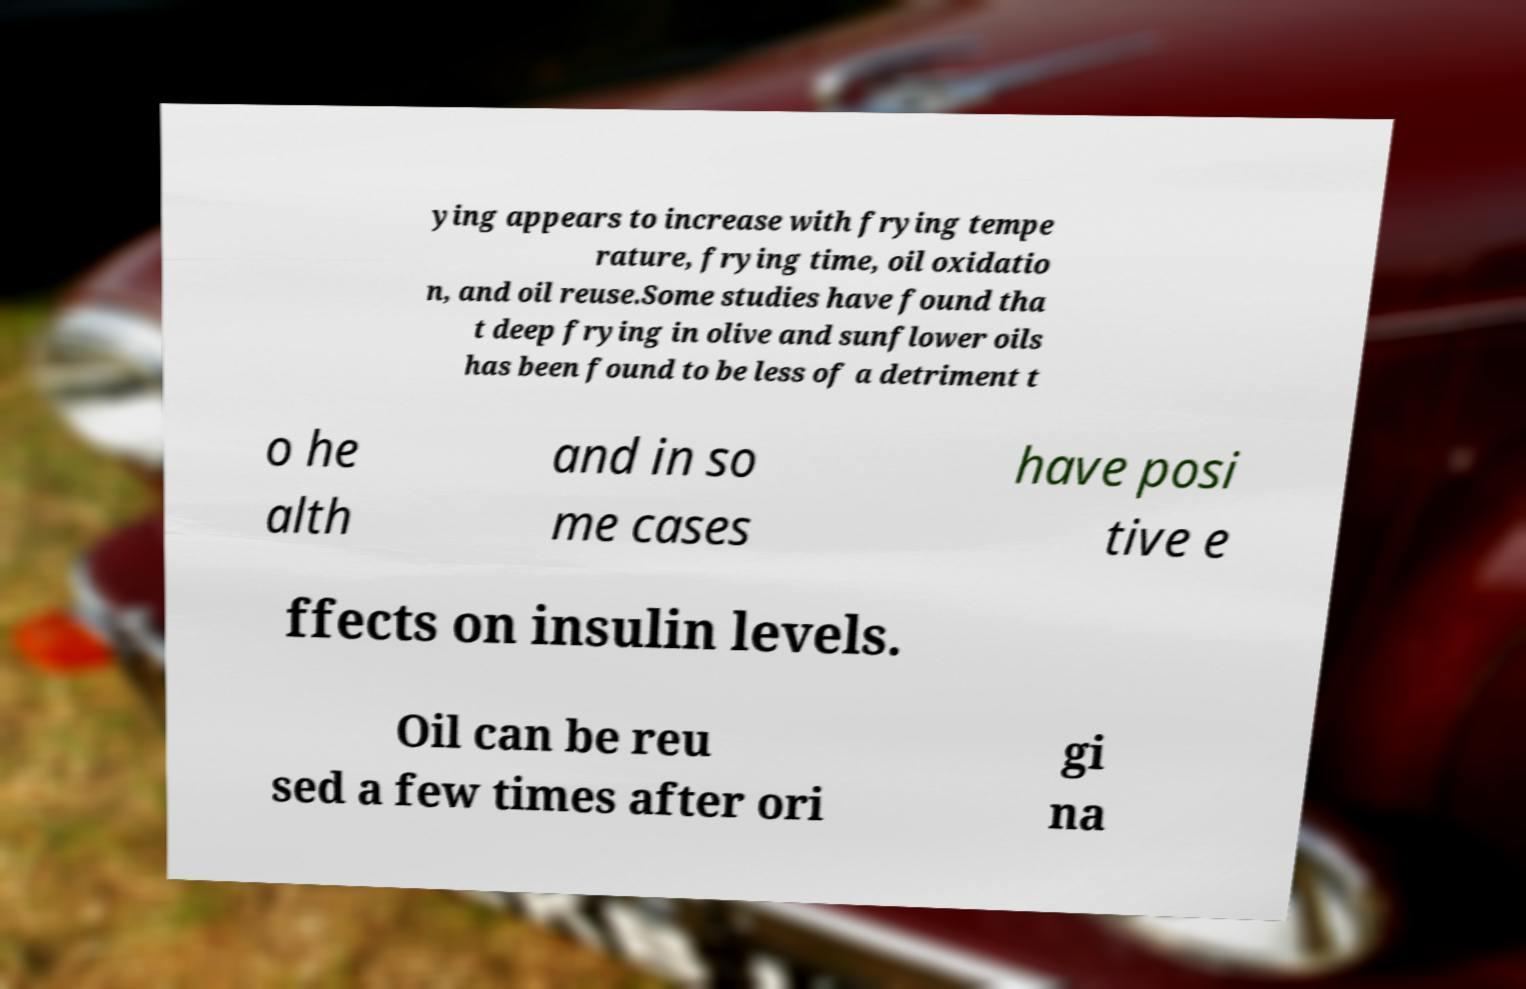Please identify and transcribe the text found in this image. ying appears to increase with frying tempe rature, frying time, oil oxidatio n, and oil reuse.Some studies have found tha t deep frying in olive and sunflower oils has been found to be less of a detriment t o he alth and in so me cases have posi tive e ffects on insulin levels. Oil can be reu sed a few times after ori gi na 